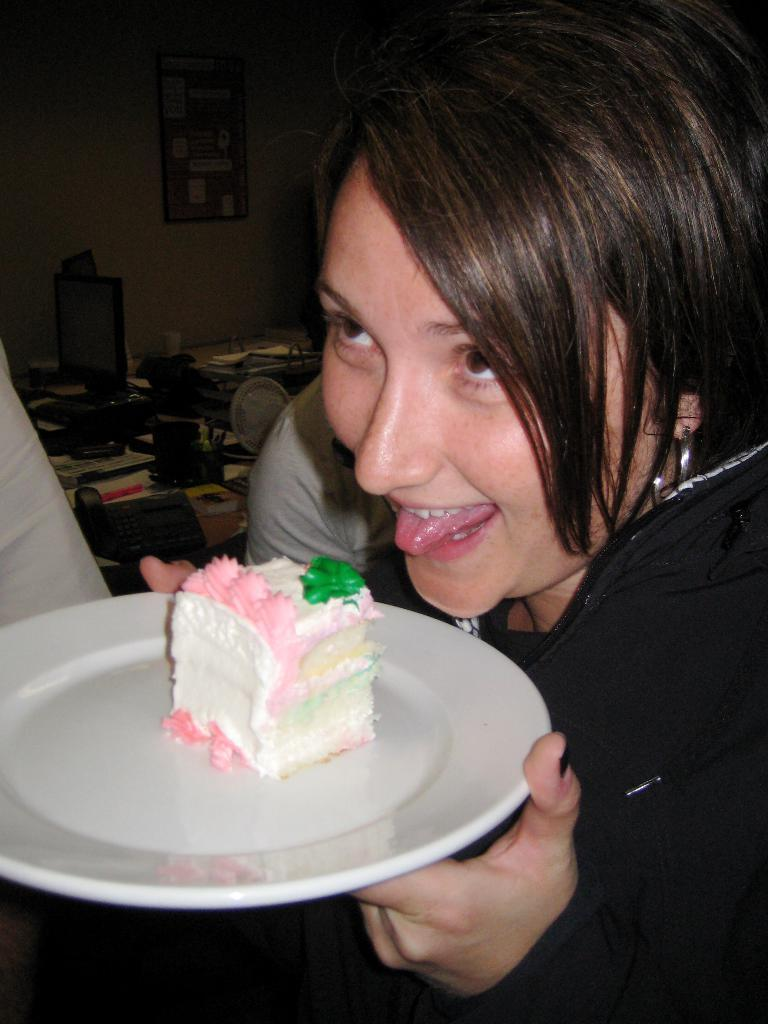What is the person holding in the image? The person is holding a plate with a cake in the image. What can be seen in the background of the image? There is a system, a telephone, objects on a table, and a board on the wall in the background of the image. How many kittens are playing with honey on the board in the image? There are no kittens or honey present in the image. What type of club is visible in the image? There is no club visible in the image. 